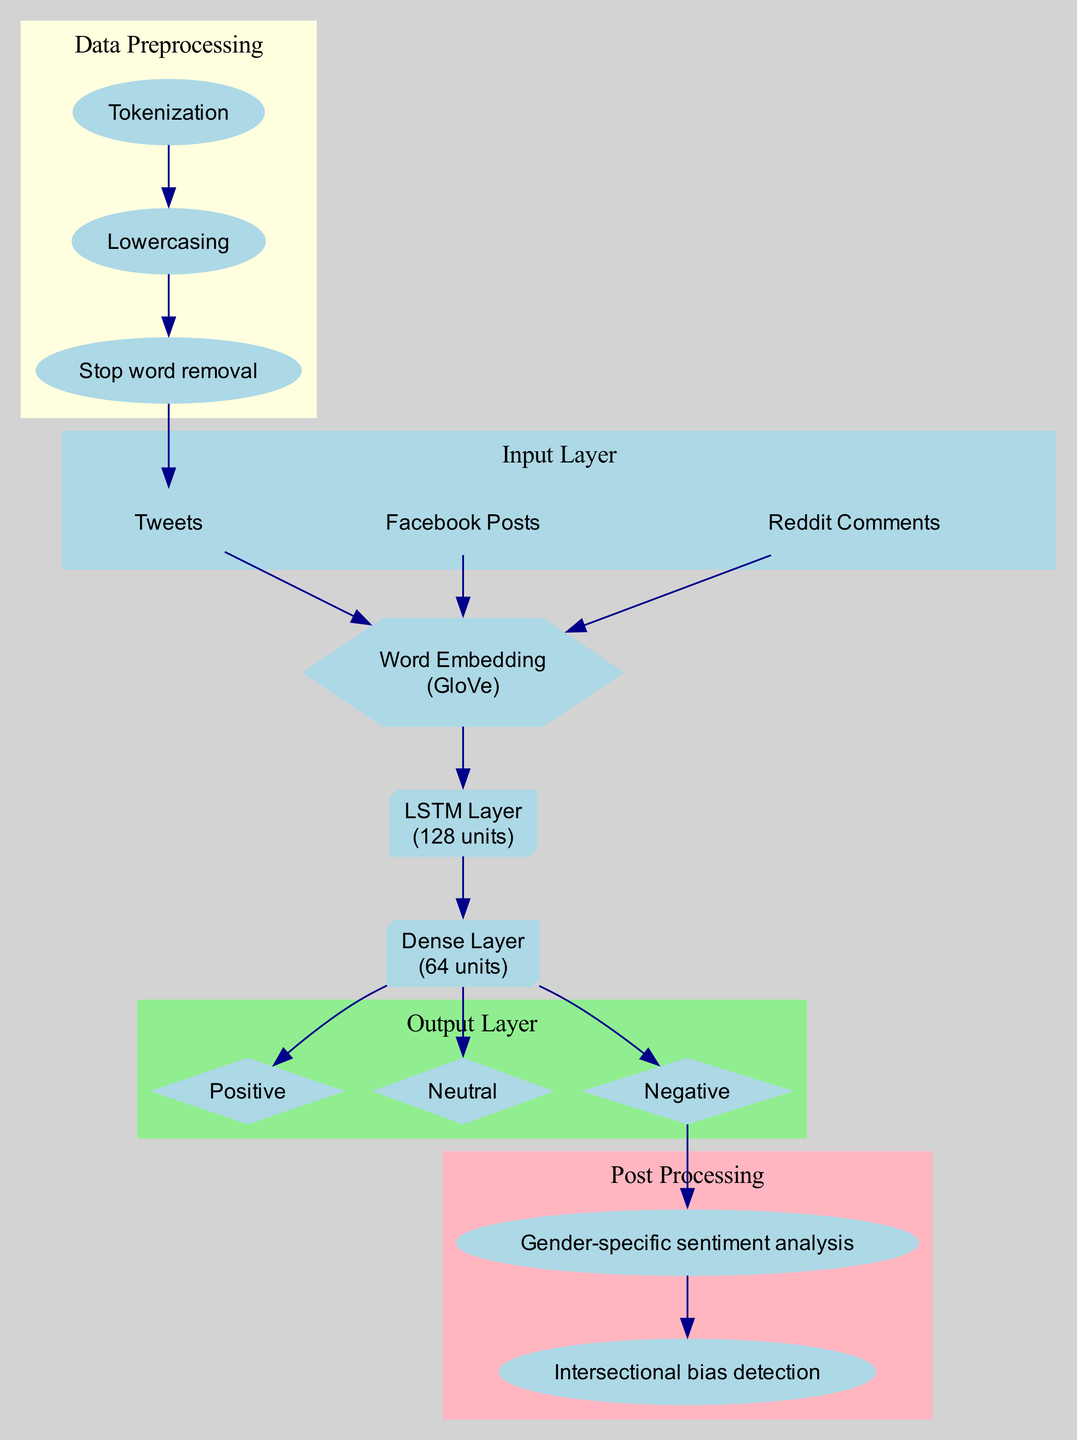What type of embedding is used in the architecture? The diagram indicates that "GloVe" is the embedding type used in the "Word Embedding" layer. This information can be found in the label of that specific layer.
Answer: GloVe How many nodes are in the output layer? The output layer consists of three nodes: "Positive," "Neutral," and "Negative," as indicated clearly in the output layer section of the diagram.
Answer: 3 What activation function is applied in the Dense Layer? The label for the Dense layer states that the activation function used is "ReLU," which is explicitly mentioned in that layer's description.
Answer: ReLU What is the unit count for the LSTM Layer? According to the diagram, the LSTM Layer is defined to have 128 units, as indicated in the node label.
Answer: 128 Which layer processes the output before sentiment classification? The Dense Layer processes output just before the sentiment classification, as the flow of connections leads from the Dense Layer to the output layer.
Answer: Dense Layer How many preprocessing steps are involved in this neural network? The diagram lists three specific preprocessing steps: "Tokenization," "Lowercasing," and "Stop word removal," which are categorized under data preprocessing.
Answer: 3 Which layer receives the input from social media discussions? The "Word Embedding" layer is the next layer that receives the input directly from the "Social Media Text Input" layer, as shown in the connection.
Answer: Word Embedding What type of analysis is conducted post processing? The diagram specifies two aspects of post-processing: "Gender-specific sentiment analysis" and "Intersectional bias detection," highlighting the focus on gender-related sentiments.
Answer: Gender-specific sentiment analysis What shape is the Word Embedding layer node in the diagram? The Word Embedding layer is represented as a hexagon shape in the diagram, which differentiates it from other layers.
Answer: Hexagon 